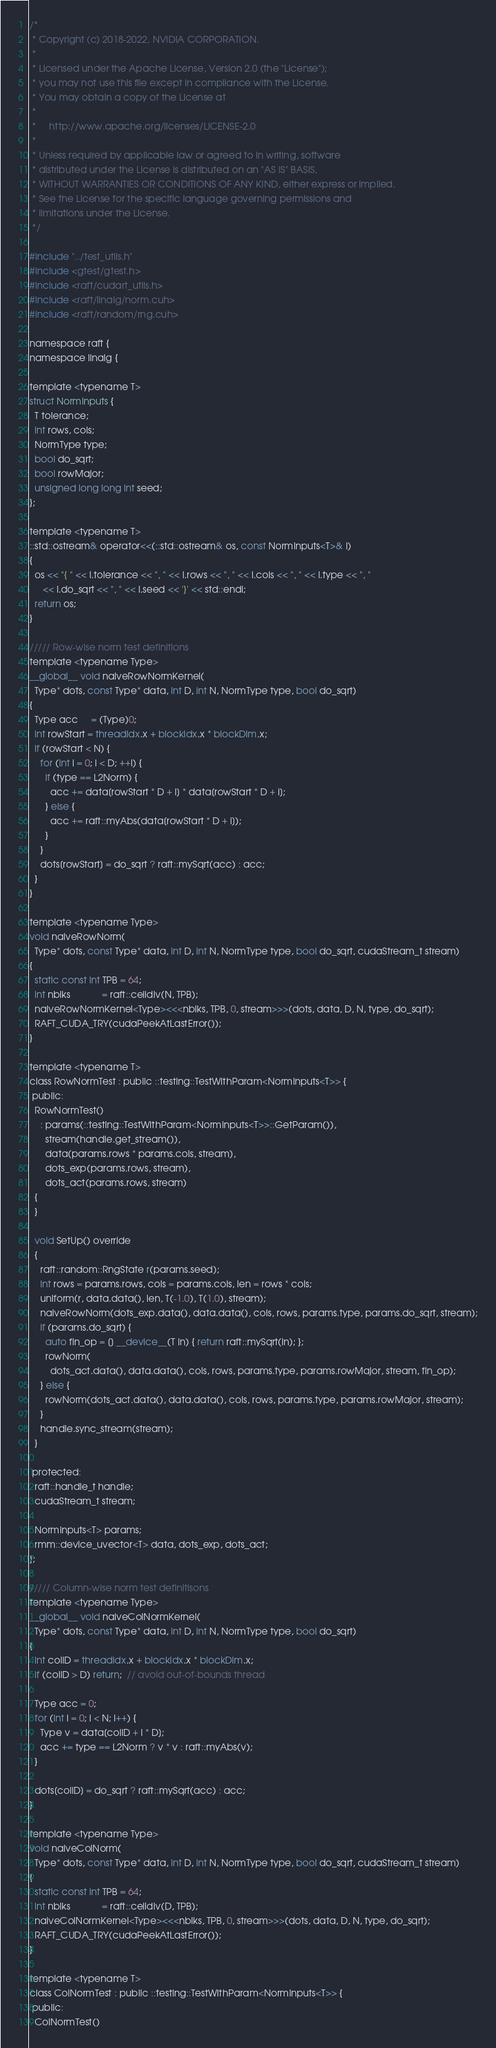Convert code to text. <code><loc_0><loc_0><loc_500><loc_500><_Cuda_>/*
 * Copyright (c) 2018-2022, NVIDIA CORPORATION.
 *
 * Licensed under the Apache License, Version 2.0 (the "License");
 * you may not use this file except in compliance with the License.
 * You may obtain a copy of the License at
 *
 *     http://www.apache.org/licenses/LICENSE-2.0
 *
 * Unless required by applicable law or agreed to in writing, software
 * distributed under the License is distributed on an "AS IS" BASIS,
 * WITHOUT WARRANTIES OR CONDITIONS OF ANY KIND, either express or implied.
 * See the License for the specific language governing permissions and
 * limitations under the License.
 */

#include "../test_utils.h"
#include <gtest/gtest.h>
#include <raft/cudart_utils.h>
#include <raft/linalg/norm.cuh>
#include <raft/random/rng.cuh>

namespace raft {
namespace linalg {

template <typename T>
struct NormInputs {
  T tolerance;
  int rows, cols;
  NormType type;
  bool do_sqrt;
  bool rowMajor;
  unsigned long long int seed;
};

template <typename T>
::std::ostream& operator<<(::std::ostream& os, const NormInputs<T>& I)
{
  os << "{ " << I.tolerance << ", " << I.rows << ", " << I.cols << ", " << I.type << ", "
     << I.do_sqrt << ", " << I.seed << '}' << std::endl;
  return os;
}

///// Row-wise norm test definitions
template <typename Type>
__global__ void naiveRowNormKernel(
  Type* dots, const Type* data, int D, int N, NormType type, bool do_sqrt)
{
  Type acc     = (Type)0;
  int rowStart = threadIdx.x + blockIdx.x * blockDim.x;
  if (rowStart < N) {
    for (int i = 0; i < D; ++i) {
      if (type == L2Norm) {
        acc += data[rowStart * D + i] * data[rowStart * D + i];
      } else {
        acc += raft::myAbs(data[rowStart * D + i]);
      }
    }
    dots[rowStart] = do_sqrt ? raft::mySqrt(acc) : acc;
  }
}

template <typename Type>
void naiveRowNorm(
  Type* dots, const Type* data, int D, int N, NormType type, bool do_sqrt, cudaStream_t stream)
{
  static const int TPB = 64;
  int nblks            = raft::ceildiv(N, TPB);
  naiveRowNormKernel<Type><<<nblks, TPB, 0, stream>>>(dots, data, D, N, type, do_sqrt);
  RAFT_CUDA_TRY(cudaPeekAtLastError());
}

template <typename T>
class RowNormTest : public ::testing::TestWithParam<NormInputs<T>> {
 public:
  RowNormTest()
    : params(::testing::TestWithParam<NormInputs<T>>::GetParam()),
      stream(handle.get_stream()),
      data(params.rows * params.cols, stream),
      dots_exp(params.rows, stream),
      dots_act(params.rows, stream)
  {
  }

  void SetUp() override
  {
    raft::random::RngState r(params.seed);
    int rows = params.rows, cols = params.cols, len = rows * cols;
    uniform(r, data.data(), len, T(-1.0), T(1.0), stream);
    naiveRowNorm(dots_exp.data(), data.data(), cols, rows, params.type, params.do_sqrt, stream);
    if (params.do_sqrt) {
      auto fin_op = [] __device__(T in) { return raft::mySqrt(in); };
      rowNorm(
        dots_act.data(), data.data(), cols, rows, params.type, params.rowMajor, stream, fin_op);
    } else {
      rowNorm(dots_act.data(), data.data(), cols, rows, params.type, params.rowMajor, stream);
    }
    handle.sync_stream(stream);
  }

 protected:
  raft::handle_t handle;
  cudaStream_t stream;

  NormInputs<T> params;
  rmm::device_uvector<T> data, dots_exp, dots_act;
};

///// Column-wise norm test definitisons
template <typename Type>
__global__ void naiveColNormKernel(
  Type* dots, const Type* data, int D, int N, NormType type, bool do_sqrt)
{
  int colID = threadIdx.x + blockIdx.x * blockDim.x;
  if (colID > D) return;  // avoid out-of-bounds thread

  Type acc = 0;
  for (int i = 0; i < N; i++) {
    Type v = data[colID + i * D];
    acc += type == L2Norm ? v * v : raft::myAbs(v);
  }

  dots[colID] = do_sqrt ? raft::mySqrt(acc) : acc;
}

template <typename Type>
void naiveColNorm(
  Type* dots, const Type* data, int D, int N, NormType type, bool do_sqrt, cudaStream_t stream)
{
  static const int TPB = 64;
  int nblks            = raft::ceildiv(D, TPB);
  naiveColNormKernel<Type><<<nblks, TPB, 0, stream>>>(dots, data, D, N, type, do_sqrt);
  RAFT_CUDA_TRY(cudaPeekAtLastError());
}

template <typename T>
class ColNormTest : public ::testing::TestWithParam<NormInputs<T>> {
 public:
  ColNormTest()</code> 